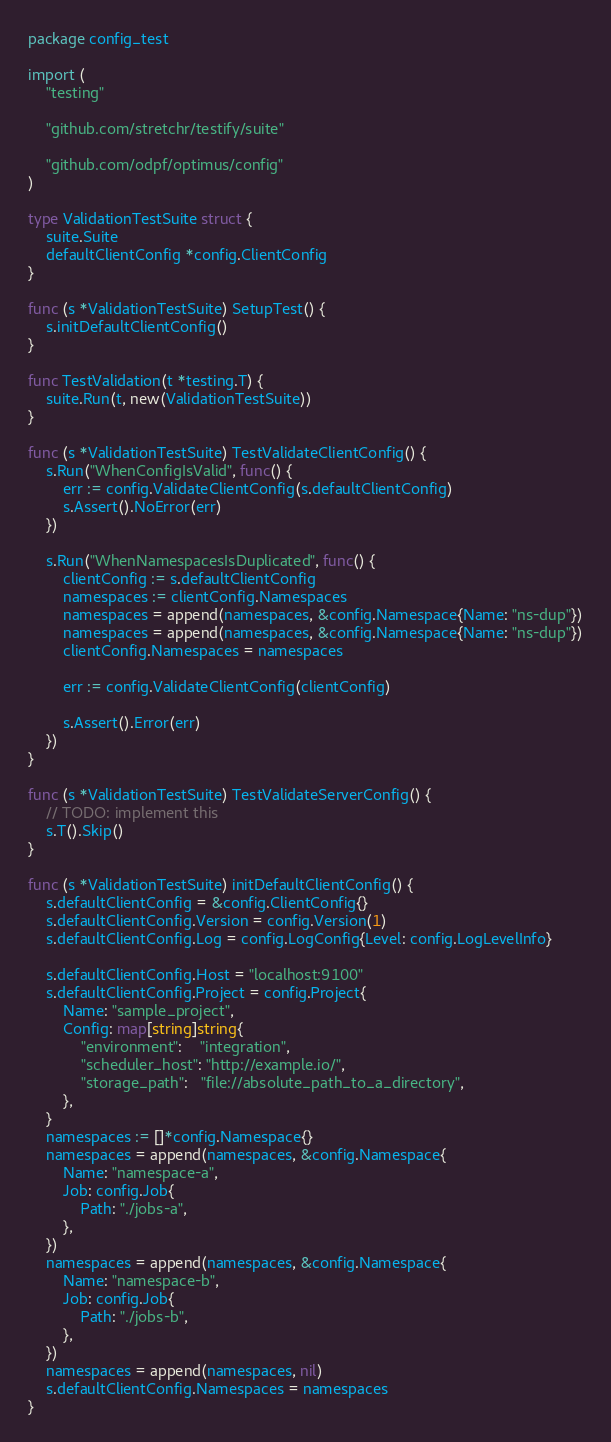Convert code to text. <code><loc_0><loc_0><loc_500><loc_500><_Go_>package config_test

import (
	"testing"

	"github.com/stretchr/testify/suite"

	"github.com/odpf/optimus/config"
)

type ValidationTestSuite struct {
	suite.Suite
	defaultClientConfig *config.ClientConfig
}

func (s *ValidationTestSuite) SetupTest() {
	s.initDefaultClientConfig()
}

func TestValidation(t *testing.T) {
	suite.Run(t, new(ValidationTestSuite))
}

func (s *ValidationTestSuite) TestValidateClientConfig() {
	s.Run("WhenConfigIsValid", func() {
		err := config.ValidateClientConfig(s.defaultClientConfig)
		s.Assert().NoError(err)
	})

	s.Run("WhenNamespacesIsDuplicated", func() {
		clientConfig := s.defaultClientConfig
		namespaces := clientConfig.Namespaces
		namespaces = append(namespaces, &config.Namespace{Name: "ns-dup"})
		namespaces = append(namespaces, &config.Namespace{Name: "ns-dup"})
		clientConfig.Namespaces = namespaces

		err := config.ValidateClientConfig(clientConfig)

		s.Assert().Error(err)
	})
}

func (s *ValidationTestSuite) TestValidateServerConfig() {
	// TODO: implement this
	s.T().Skip()
}

func (s *ValidationTestSuite) initDefaultClientConfig() {
	s.defaultClientConfig = &config.ClientConfig{}
	s.defaultClientConfig.Version = config.Version(1)
	s.defaultClientConfig.Log = config.LogConfig{Level: config.LogLevelInfo}

	s.defaultClientConfig.Host = "localhost:9100"
	s.defaultClientConfig.Project = config.Project{
		Name: "sample_project",
		Config: map[string]string{
			"environment":    "integration",
			"scheduler_host": "http://example.io/",
			"storage_path":   "file://absolute_path_to_a_directory",
		},
	}
	namespaces := []*config.Namespace{}
	namespaces = append(namespaces, &config.Namespace{
		Name: "namespace-a",
		Job: config.Job{
			Path: "./jobs-a",
		},
	})
	namespaces = append(namespaces, &config.Namespace{
		Name: "namespace-b",
		Job: config.Job{
			Path: "./jobs-b",
		},
	})
	namespaces = append(namespaces, nil)
	s.defaultClientConfig.Namespaces = namespaces
}
</code> 